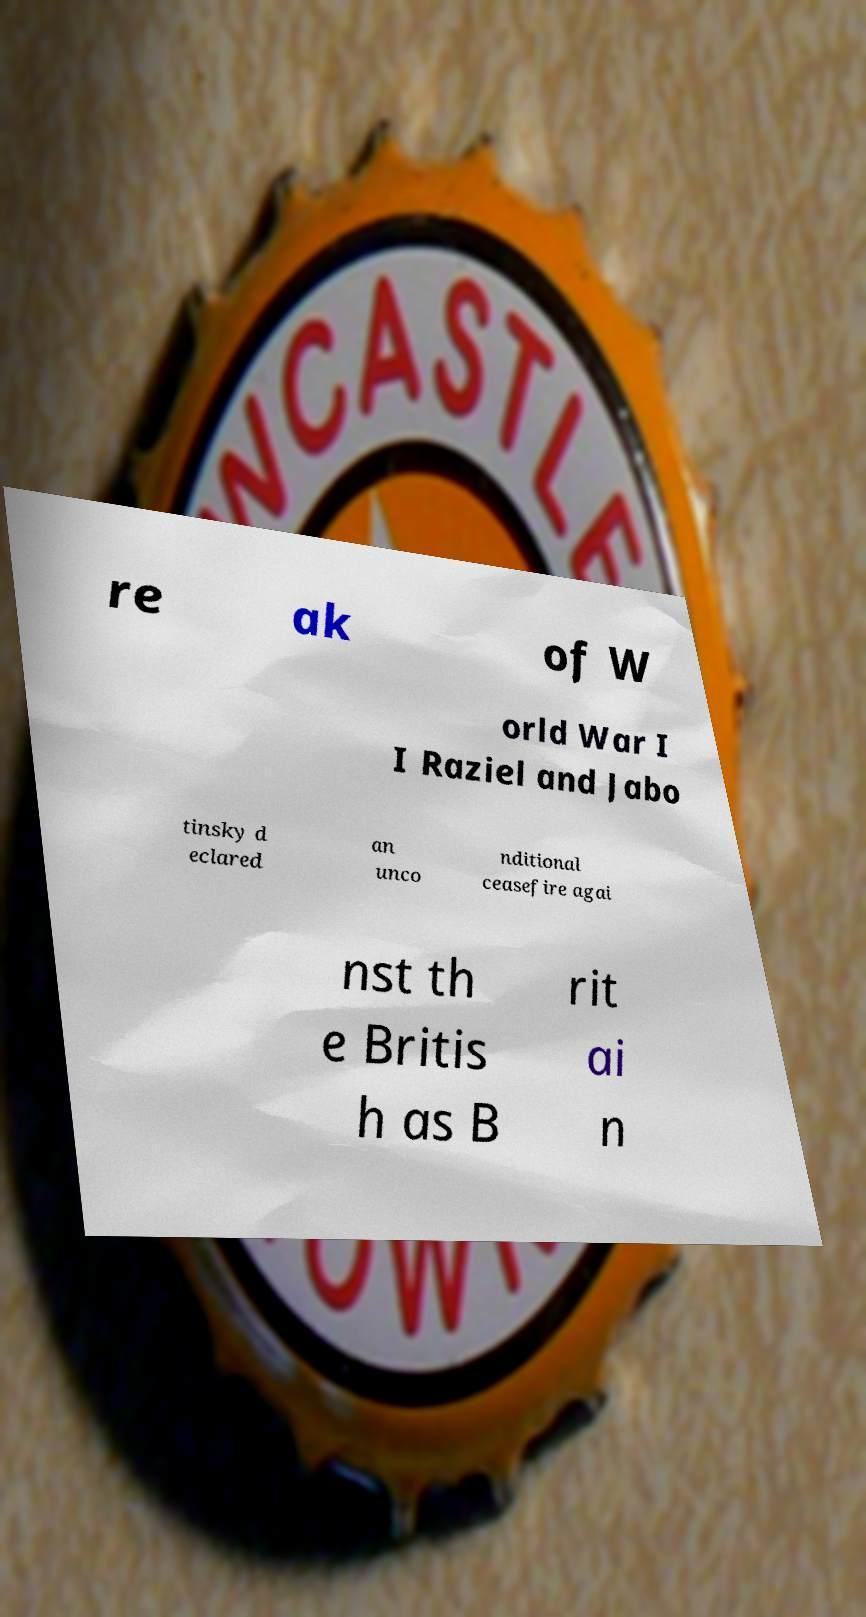Could you extract and type out the text from this image? re ak of W orld War I I Raziel and Jabo tinsky d eclared an unco nditional ceasefire agai nst th e Britis h as B rit ai n 